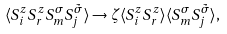Convert formula to latex. <formula><loc_0><loc_0><loc_500><loc_500>\langle S _ { i } ^ { z } S _ { r } ^ { z } S _ { m } ^ { \sigma } S _ { j } ^ { \tilde { \sigma } } \rangle \rightarrow \zeta \langle S _ { i } ^ { z } S _ { r } ^ { z } \rangle \langle S _ { m } ^ { \sigma } S _ { j } ^ { \tilde { \sigma } } \rangle ,</formula> 